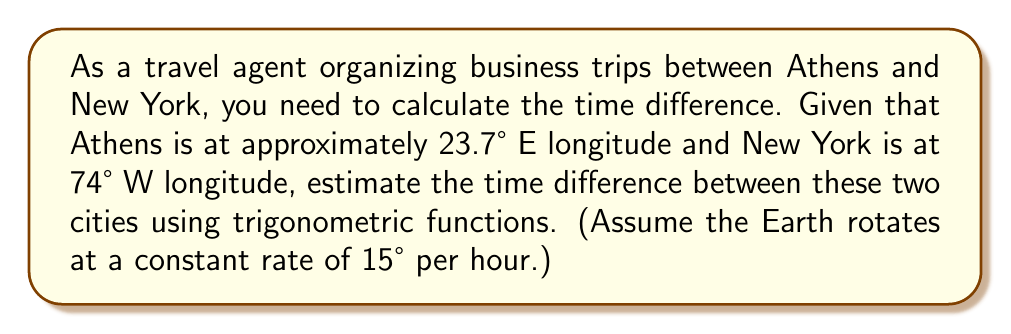Give your solution to this math problem. To solve this problem, we'll follow these steps:

1) First, calculate the total longitudinal difference between Athens and New York:
   $\Delta\text{longitude} = 23.7° + 74° = 97.7°$

2) The Earth rotates 360° in 24 hours, which means it rotates 15° per hour. We can set up a proportion:
   $$\frac{15°}{1\text{ hour}} = \frac{97.7°}{x\text{ hours}}$$

3) Cross multiply:
   $15x = 97.7$

4) Solve for x:
   $$x = \frac{97.7}{15} = 6.513333...\text{ hours}$$

5) Convert the decimal part to minutes:
   $0.513333... \times 60 \text{ minutes} = 30.8 \text{ minutes}$

6) Round to the nearest minute:
   6 hours and 31 minutes

Therefore, when it's noon in Athens, it's approximately 5:29 AM in New York.

Note: In reality, time zones are often adjusted for political and geographical reasons, so the actual time difference might be slightly different. This calculation gives the theoretical time difference based purely on longitude.
Answer: 6 hours and 31 minutes 